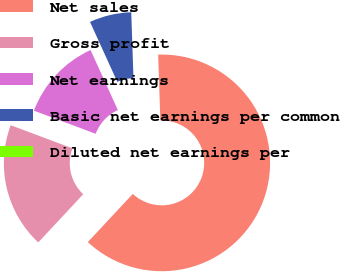Convert chart. <chart><loc_0><loc_0><loc_500><loc_500><pie_chart><fcel>Net sales<fcel>Gross profit<fcel>Net earnings<fcel>Basic net earnings per common<fcel>Diluted net earnings per<nl><fcel>62.47%<fcel>18.75%<fcel>12.5%<fcel>6.26%<fcel>0.01%<nl></chart> 